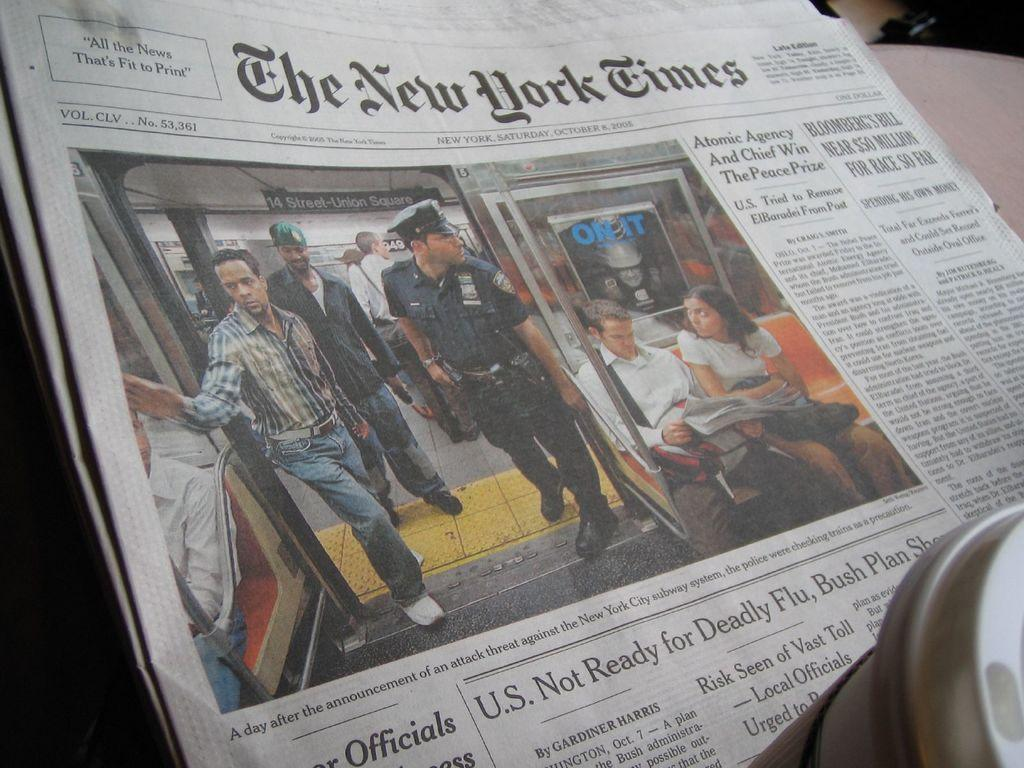What is the primary subject of the paper in the image? People are depicted on the paper in the image. What type of paper is it? It is new paper. Where is the river flowing in the image? There is no river present in the image; it only features new paper with people depicted on it. 